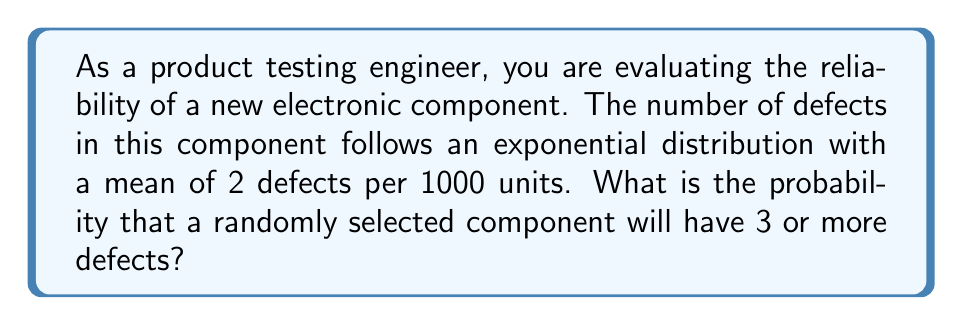Provide a solution to this math problem. Let's approach this step-by-step:

1) The exponential distribution is given by the probability density function:
   $$ f(x) = \lambda e^{-\lambda x} $$
   where $\lambda$ is the rate parameter.

2) We're given that the mean is 2 defects per 1000 units. For an exponential distribution, the mean is $\frac{1}{\lambda}$. So:
   $$ \frac{1}{\lambda} = \frac{2}{1000} $$
   $$ \lambda = \frac{1000}{2} = 500 $$

3) We want to find P(X ≥ 3), where X is the number of defects. This is equivalent to 1 - P(X < 3).

4) For a continuous distribution, P(X < 3) is the same as P(X ≤ 3). The cumulative distribution function for an exponential distribution is:
   $$ F(x) = 1 - e^{-\lambda x} $$

5) Therefore:
   $$ P(X \geq 3) = 1 - P(X < 3) = 1 - (1 - e^{-500 \cdot 3/1000}) = e^{-1.5} $$

6) Calculate this value:
   $$ e^{-1.5} \approx 0.2231 $$

Thus, the probability of a randomly selected component having 3 or more defects is approximately 0.2231 or 22.31%.
Answer: 0.2231 